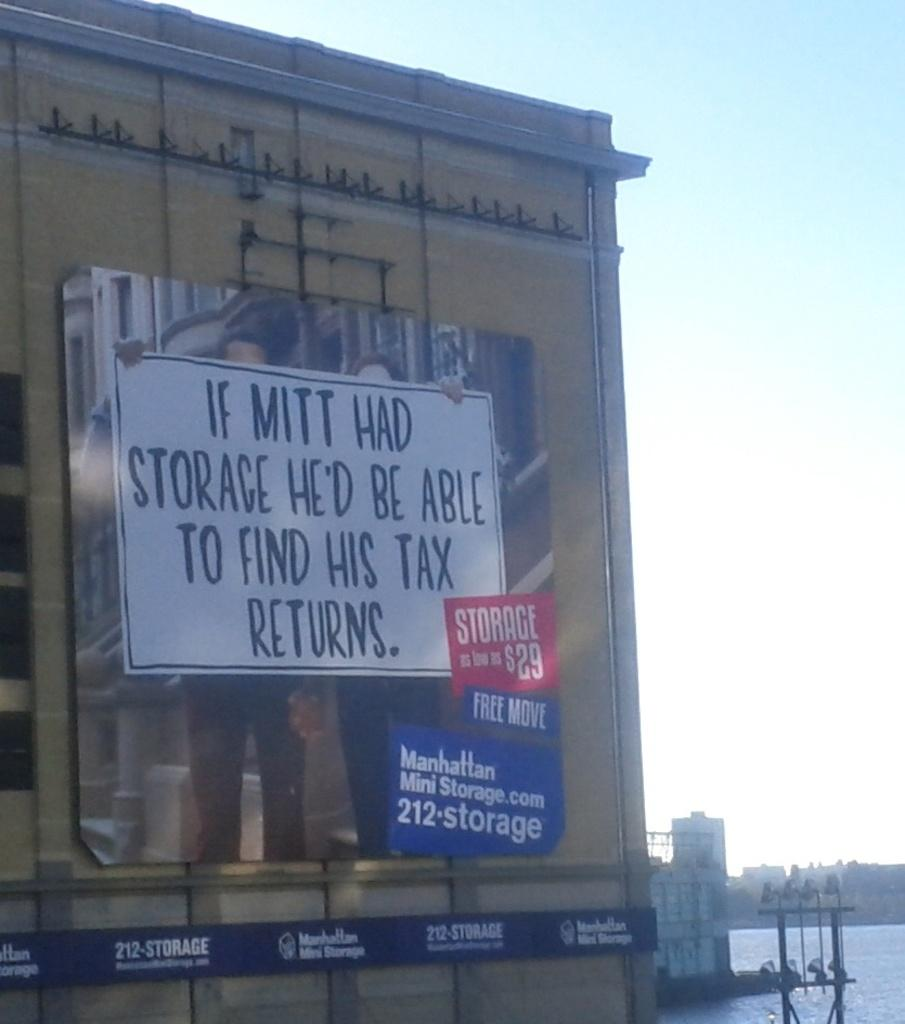<image>
Give a short and clear explanation of the subsequent image. A billboard message saying If Mitt had storage he'd be able to find his tax returns 